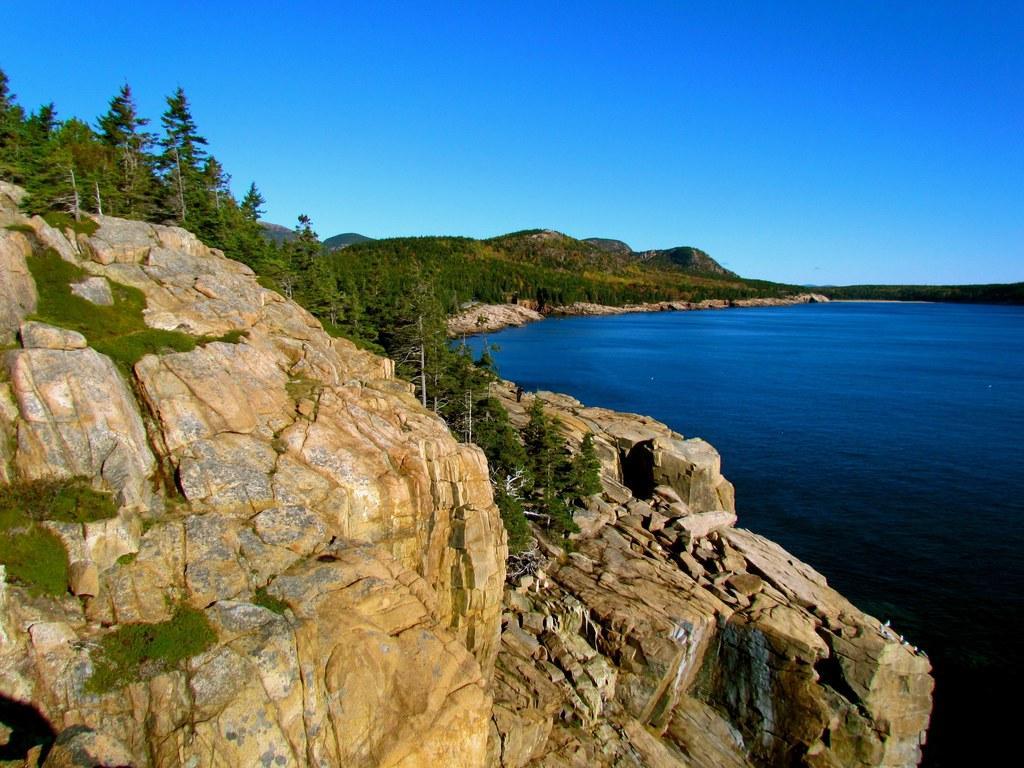Can you describe this image briefly? In this image there are mountains, trees, river and the sky. 